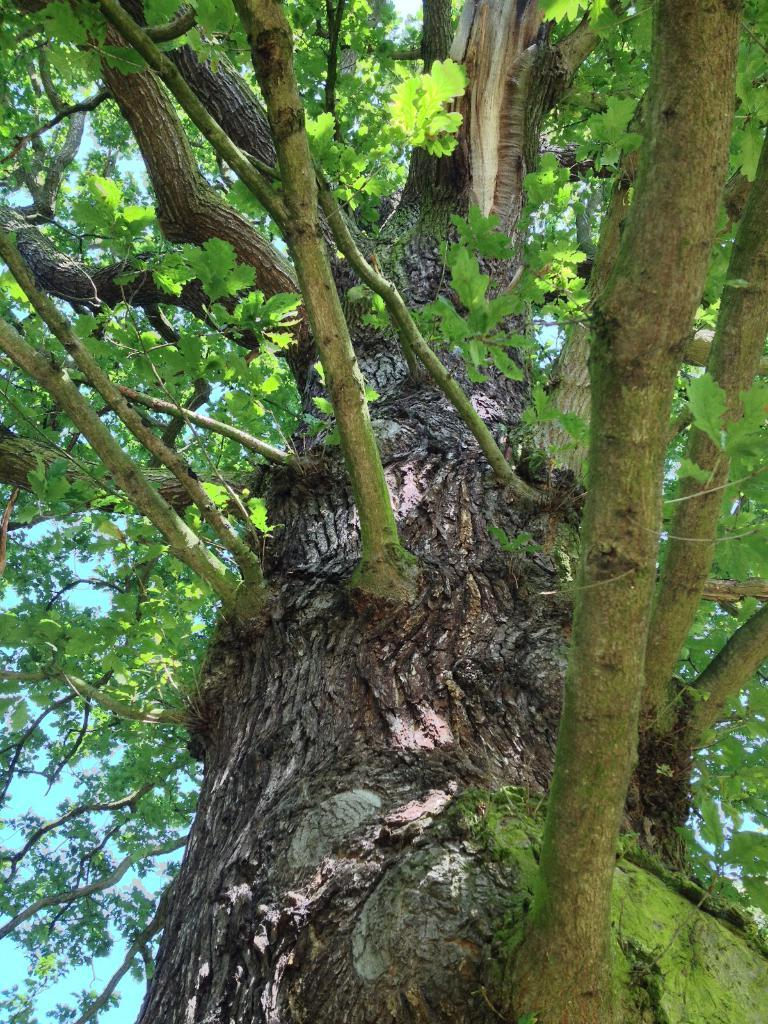What type of plant can be seen in the image? There is a tree in the image. What part of the tree is visible in the image? The tree has a branch in the image. What is attached to the branch of the tree? The branch has stems andems and leaves in the image. What is visible in the background of the image? The sky is visible in the image. What type of pen is being used to write on the tree in the image? There is no pen or writing present on the tree in the image. How does the street look like in the image? There is no street visible in the image; it features a tree with a branch, stems, and leaves. 